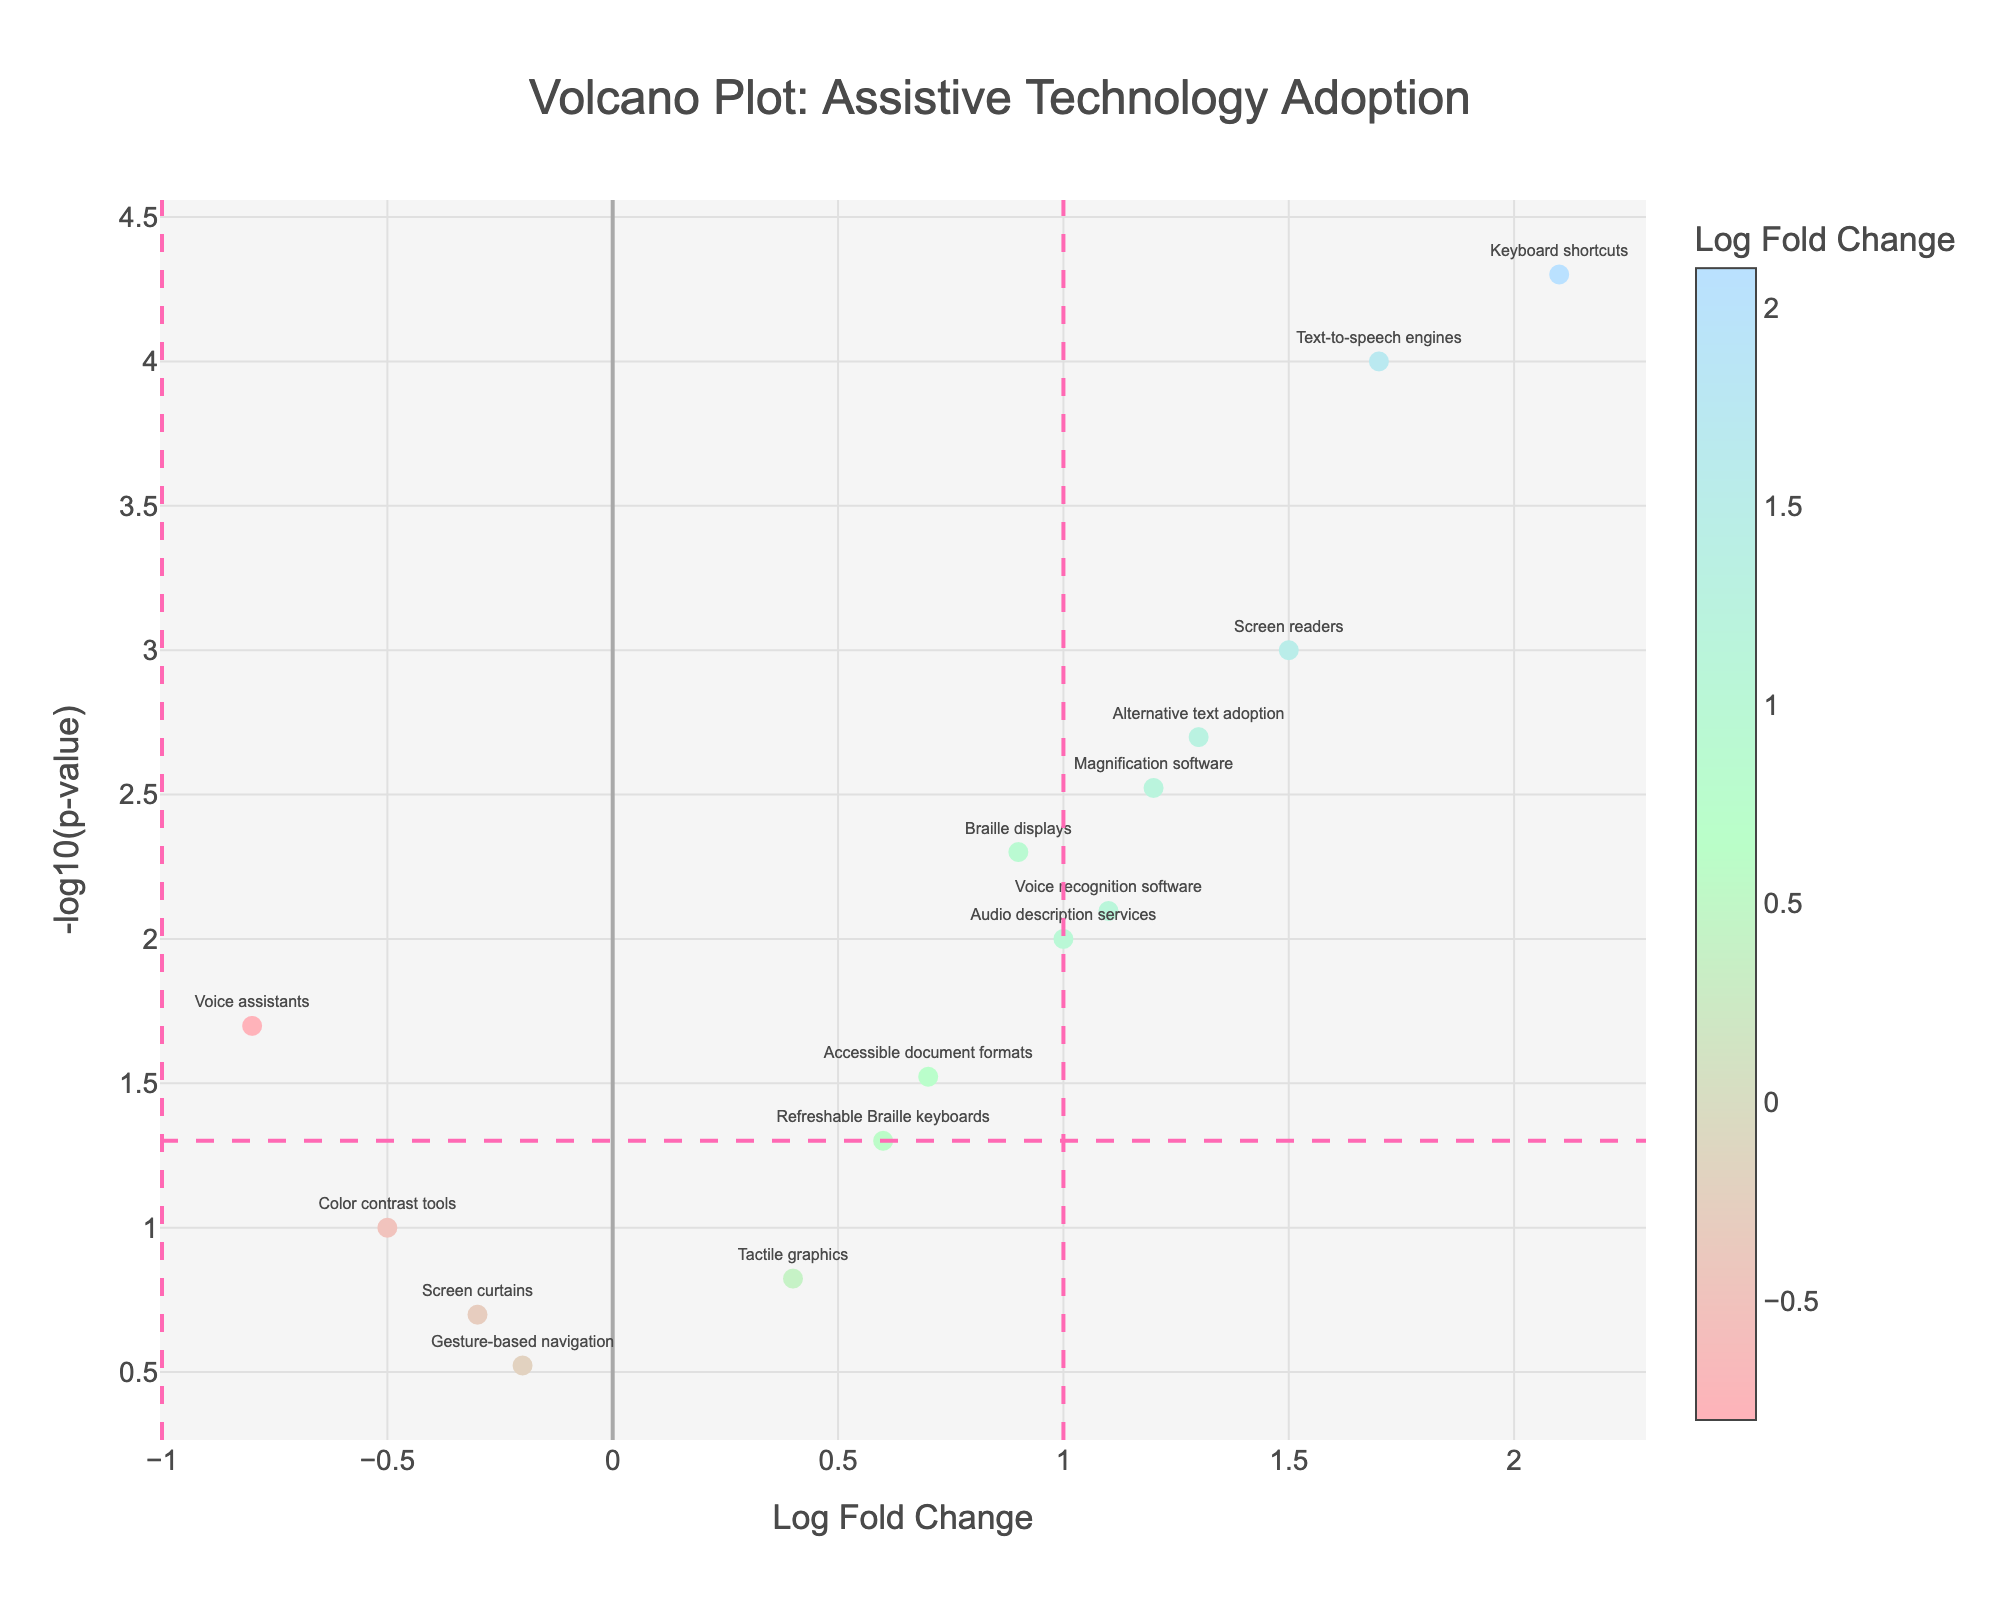What's the title of the plot? The title is typically located at the top of the figure and often provides a summary of what the figure represents. In this case, the title is "Volcano Plot: Assistive Technology Adoption"
Answer: Volcano Plot: Assistive Technology Adoption What is represented on the x-axis and y-axis? The axes are labeled to indicate what they represent. The x-axis represents "Log Fold Change," and the y-axis represents "-log10(p-value)."
Answer: Log Fold Change and -log10(p-value) How many data points represent assistive technologies with significant adoption rates (p < 0.05) and elevated usage (LogFoldChange > 1)? The horizontal line at -log10(0.05) indicates a significance threshold, and the vertical line at LogFoldChange = 1 indicates elevated usage. Technologies above this line and to the right of LogFoldChange = 1 have significant adoption rates and elevated usage. From the plot, these data points are Text-to-speech engines, Keyboard shortcuts, Screen readers, Magnification software, and Alternative text adoption, totaling 5.
Answer: 5 Which assistive technology has the highest log fold change? The highest point on the x-axis corresponds to the technology with the greatest positive log fold change. In this case, Keyboard shortcuts has the highest log fold change.
Answer: Keyboard shortcuts How many assistive technologies have a negative log fold change? The x-axis midpoint (LogFoldChange = 0) separates positive from negative values. Counting the points to the left of this midpoint, there are three negative LogFoldChange values for Voice assistants, Color contrast tools, and Gesture-based navigation.
Answer: 3 Among the technologies with significant p-values (p < 0.05), which has the lowest log fold change? Significant p-values are indicated above the horizontal line at -log10(0.05). Among these points, the one with the lowest log fold change value (closest to the left) is Voice assistants.
Answer: Voice assistants Comparing 'Screen readers' and 'Voice assistants', which technology has a more significant p-value, and by how much? To compare the p-values, convert -log10(p-value) back to p-value. Screen readers have a p-value of 0.001 (-log10(0.001) = 3), and Voice assistants have a p-value of 0.02 (-log10(0.02) ≈ 1.7). So, Screen readers have a more significant p-value. The difference is 0.001 - 0.02 = -0.019.
Answer: Screen readers by 0.019 What are the assistive technologies near the non-significant p-value threshold (just below -log10(0.05))? The horizontal line at -log10(0.05) marks the p-value threshold for significance. Technologies just below this line with their points touching or slightly below it are Refreshable Braille keyboards.
Answer: Refreshable Braille keyboards Which assistive technology appears to be the least statistically significant? The lowest position on the y-axis (closest to zero) represents the least statistically significant technology. Gesture-based navigation appears to be the least significant as it is closest to the x-axis.
Answer: Gesture-based navigation 